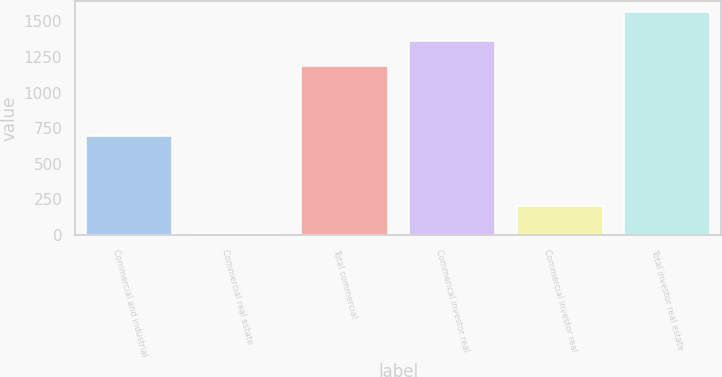Convert chart to OTSL. <chart><loc_0><loc_0><loc_500><loc_500><bar_chart><fcel>Commercial and industrial<fcel>Commercial real estate<fcel>Total commercial<fcel>Commerical investor real<fcel>Commercial investor real<fcel>Total investor real estate<nl><fcel>696.2<fcel>10<fcel>1185<fcel>1361<fcel>201<fcel>1562<nl></chart> 